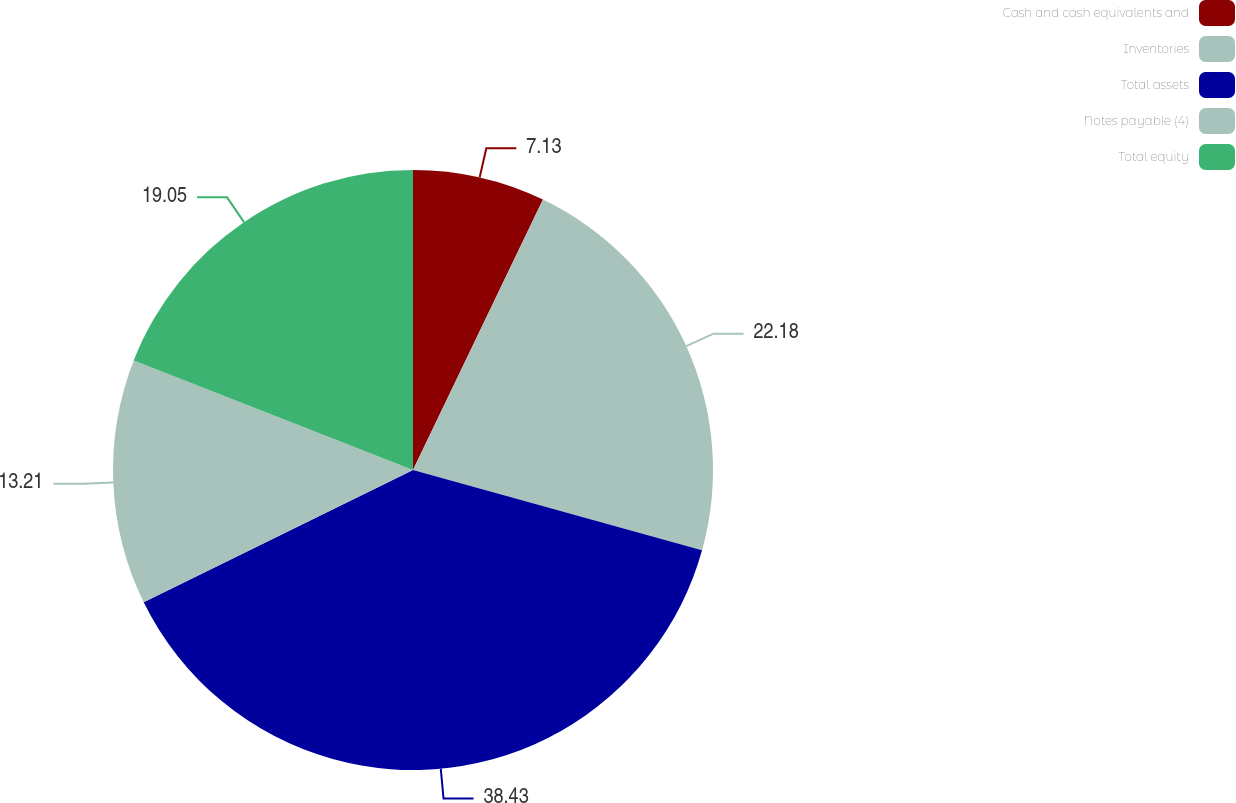Convert chart to OTSL. <chart><loc_0><loc_0><loc_500><loc_500><pie_chart><fcel>Cash and cash equivalents and<fcel>Inventories<fcel>Total assets<fcel>Notes payable (4)<fcel>Total equity<nl><fcel>7.13%<fcel>22.18%<fcel>38.42%<fcel>13.21%<fcel>19.05%<nl></chart> 